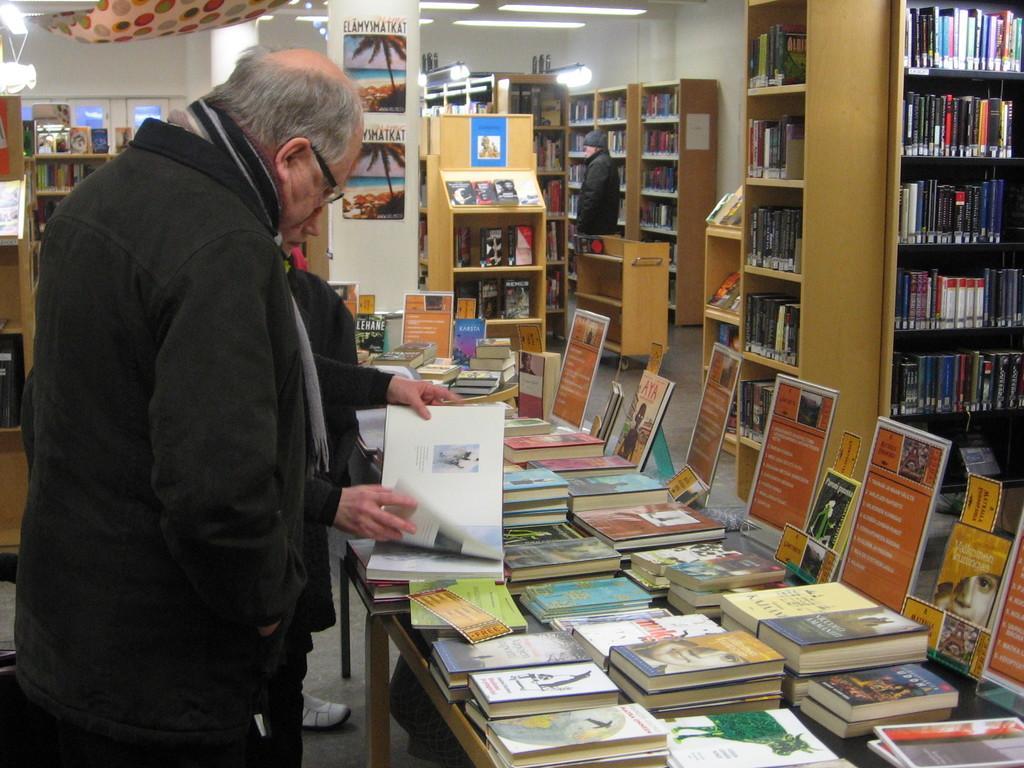Could you give a brief overview of what you see in this image? There are two persons standing in front of a table which has many books on it and there are many bookshelves around them. 